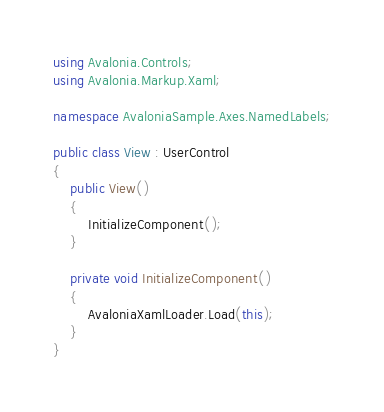Convert code to text. <code><loc_0><loc_0><loc_500><loc_500><_C#_>using Avalonia.Controls;
using Avalonia.Markup.Xaml;

namespace AvaloniaSample.Axes.NamedLabels;

public class View : UserControl
{
    public View()
    {
        InitializeComponent();
    }

    private void InitializeComponent()
    {
        AvaloniaXamlLoader.Load(this);
    }
}
</code> 